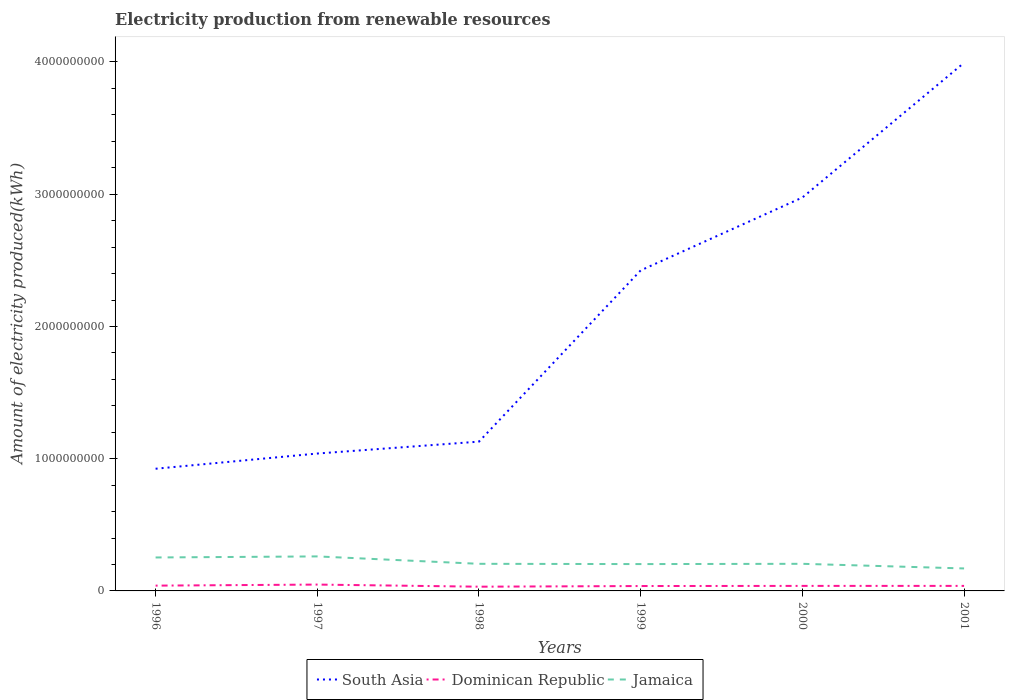Does the line corresponding to Dominican Republic intersect with the line corresponding to South Asia?
Give a very brief answer. No. Across all years, what is the maximum amount of electricity produced in South Asia?
Ensure brevity in your answer.  9.24e+08. In which year was the amount of electricity produced in Dominican Republic maximum?
Make the answer very short. 1998. What is the total amount of electricity produced in Dominican Republic in the graph?
Give a very brief answer. 2.00e+06. What is the difference between the highest and the second highest amount of electricity produced in Dominican Republic?
Give a very brief answer. 1.60e+07. What is the difference between the highest and the lowest amount of electricity produced in South Asia?
Make the answer very short. 3. Is the amount of electricity produced in South Asia strictly greater than the amount of electricity produced in Jamaica over the years?
Offer a very short reply. No. How many lines are there?
Make the answer very short. 3. How many years are there in the graph?
Your response must be concise. 6. Are the values on the major ticks of Y-axis written in scientific E-notation?
Keep it short and to the point. No. Does the graph contain grids?
Offer a very short reply. No. Where does the legend appear in the graph?
Keep it short and to the point. Bottom center. How many legend labels are there?
Ensure brevity in your answer.  3. How are the legend labels stacked?
Provide a succinct answer. Horizontal. What is the title of the graph?
Ensure brevity in your answer.  Electricity production from renewable resources. What is the label or title of the X-axis?
Offer a terse response. Years. What is the label or title of the Y-axis?
Give a very brief answer. Amount of electricity produced(kWh). What is the Amount of electricity produced(kWh) in South Asia in 1996?
Keep it short and to the point. 9.24e+08. What is the Amount of electricity produced(kWh) in Dominican Republic in 1996?
Offer a terse response. 4.00e+07. What is the Amount of electricity produced(kWh) of Jamaica in 1996?
Make the answer very short. 2.53e+08. What is the Amount of electricity produced(kWh) of South Asia in 1997?
Make the answer very short. 1.04e+09. What is the Amount of electricity produced(kWh) of Dominican Republic in 1997?
Offer a terse response. 4.80e+07. What is the Amount of electricity produced(kWh) in Jamaica in 1997?
Keep it short and to the point. 2.61e+08. What is the Amount of electricity produced(kWh) in South Asia in 1998?
Give a very brief answer. 1.13e+09. What is the Amount of electricity produced(kWh) in Dominican Republic in 1998?
Your response must be concise. 3.20e+07. What is the Amount of electricity produced(kWh) in Jamaica in 1998?
Provide a succinct answer. 2.05e+08. What is the Amount of electricity produced(kWh) in South Asia in 1999?
Keep it short and to the point. 2.42e+09. What is the Amount of electricity produced(kWh) of Dominican Republic in 1999?
Provide a succinct answer. 3.70e+07. What is the Amount of electricity produced(kWh) of Jamaica in 1999?
Give a very brief answer. 2.03e+08. What is the Amount of electricity produced(kWh) of South Asia in 2000?
Make the answer very short. 2.98e+09. What is the Amount of electricity produced(kWh) of Dominican Republic in 2000?
Keep it short and to the point. 3.80e+07. What is the Amount of electricity produced(kWh) of Jamaica in 2000?
Keep it short and to the point. 2.05e+08. What is the Amount of electricity produced(kWh) in South Asia in 2001?
Your answer should be very brief. 3.99e+09. What is the Amount of electricity produced(kWh) in Dominican Republic in 2001?
Your response must be concise. 3.80e+07. What is the Amount of electricity produced(kWh) of Jamaica in 2001?
Your answer should be very brief. 1.70e+08. Across all years, what is the maximum Amount of electricity produced(kWh) in South Asia?
Your answer should be very brief. 3.99e+09. Across all years, what is the maximum Amount of electricity produced(kWh) of Dominican Republic?
Make the answer very short. 4.80e+07. Across all years, what is the maximum Amount of electricity produced(kWh) of Jamaica?
Your answer should be compact. 2.61e+08. Across all years, what is the minimum Amount of electricity produced(kWh) in South Asia?
Offer a very short reply. 9.24e+08. Across all years, what is the minimum Amount of electricity produced(kWh) in Dominican Republic?
Your answer should be very brief. 3.20e+07. Across all years, what is the minimum Amount of electricity produced(kWh) in Jamaica?
Offer a terse response. 1.70e+08. What is the total Amount of electricity produced(kWh) of South Asia in the graph?
Make the answer very short. 1.25e+1. What is the total Amount of electricity produced(kWh) in Dominican Republic in the graph?
Your answer should be very brief. 2.33e+08. What is the total Amount of electricity produced(kWh) of Jamaica in the graph?
Give a very brief answer. 1.30e+09. What is the difference between the Amount of electricity produced(kWh) in South Asia in 1996 and that in 1997?
Offer a terse response. -1.15e+08. What is the difference between the Amount of electricity produced(kWh) of Dominican Republic in 1996 and that in 1997?
Make the answer very short. -8.00e+06. What is the difference between the Amount of electricity produced(kWh) in Jamaica in 1996 and that in 1997?
Offer a very short reply. -8.00e+06. What is the difference between the Amount of electricity produced(kWh) of South Asia in 1996 and that in 1998?
Provide a short and direct response. -2.05e+08. What is the difference between the Amount of electricity produced(kWh) in Dominican Republic in 1996 and that in 1998?
Give a very brief answer. 8.00e+06. What is the difference between the Amount of electricity produced(kWh) in Jamaica in 1996 and that in 1998?
Provide a short and direct response. 4.80e+07. What is the difference between the Amount of electricity produced(kWh) of South Asia in 1996 and that in 1999?
Your answer should be compact. -1.50e+09. What is the difference between the Amount of electricity produced(kWh) in Dominican Republic in 1996 and that in 1999?
Your answer should be very brief. 3.00e+06. What is the difference between the Amount of electricity produced(kWh) in South Asia in 1996 and that in 2000?
Your answer should be very brief. -2.05e+09. What is the difference between the Amount of electricity produced(kWh) of Dominican Republic in 1996 and that in 2000?
Your answer should be very brief. 2.00e+06. What is the difference between the Amount of electricity produced(kWh) in Jamaica in 1996 and that in 2000?
Give a very brief answer. 4.80e+07. What is the difference between the Amount of electricity produced(kWh) in South Asia in 1996 and that in 2001?
Ensure brevity in your answer.  -3.07e+09. What is the difference between the Amount of electricity produced(kWh) of Dominican Republic in 1996 and that in 2001?
Your answer should be very brief. 2.00e+06. What is the difference between the Amount of electricity produced(kWh) of Jamaica in 1996 and that in 2001?
Offer a very short reply. 8.30e+07. What is the difference between the Amount of electricity produced(kWh) of South Asia in 1997 and that in 1998?
Offer a terse response. -9.00e+07. What is the difference between the Amount of electricity produced(kWh) of Dominican Republic in 1997 and that in 1998?
Your answer should be compact. 1.60e+07. What is the difference between the Amount of electricity produced(kWh) in Jamaica in 1997 and that in 1998?
Ensure brevity in your answer.  5.60e+07. What is the difference between the Amount of electricity produced(kWh) of South Asia in 1997 and that in 1999?
Your answer should be compact. -1.38e+09. What is the difference between the Amount of electricity produced(kWh) in Dominican Republic in 1997 and that in 1999?
Ensure brevity in your answer.  1.10e+07. What is the difference between the Amount of electricity produced(kWh) in Jamaica in 1997 and that in 1999?
Make the answer very short. 5.80e+07. What is the difference between the Amount of electricity produced(kWh) in South Asia in 1997 and that in 2000?
Give a very brief answer. -1.94e+09. What is the difference between the Amount of electricity produced(kWh) in Jamaica in 1997 and that in 2000?
Your answer should be compact. 5.60e+07. What is the difference between the Amount of electricity produced(kWh) of South Asia in 1997 and that in 2001?
Provide a succinct answer. -2.96e+09. What is the difference between the Amount of electricity produced(kWh) in Dominican Republic in 1997 and that in 2001?
Make the answer very short. 1.00e+07. What is the difference between the Amount of electricity produced(kWh) in Jamaica in 1997 and that in 2001?
Your answer should be compact. 9.10e+07. What is the difference between the Amount of electricity produced(kWh) in South Asia in 1998 and that in 1999?
Keep it short and to the point. -1.30e+09. What is the difference between the Amount of electricity produced(kWh) in Dominican Republic in 1998 and that in 1999?
Offer a terse response. -5.00e+06. What is the difference between the Amount of electricity produced(kWh) of South Asia in 1998 and that in 2000?
Provide a short and direct response. -1.85e+09. What is the difference between the Amount of electricity produced(kWh) in Dominican Republic in 1998 and that in 2000?
Provide a succinct answer. -6.00e+06. What is the difference between the Amount of electricity produced(kWh) in Jamaica in 1998 and that in 2000?
Give a very brief answer. 0. What is the difference between the Amount of electricity produced(kWh) in South Asia in 1998 and that in 2001?
Ensure brevity in your answer.  -2.86e+09. What is the difference between the Amount of electricity produced(kWh) of Dominican Republic in 1998 and that in 2001?
Your answer should be compact. -6.00e+06. What is the difference between the Amount of electricity produced(kWh) of Jamaica in 1998 and that in 2001?
Ensure brevity in your answer.  3.50e+07. What is the difference between the Amount of electricity produced(kWh) in South Asia in 1999 and that in 2000?
Offer a terse response. -5.51e+08. What is the difference between the Amount of electricity produced(kWh) of Dominican Republic in 1999 and that in 2000?
Give a very brief answer. -1.00e+06. What is the difference between the Amount of electricity produced(kWh) of South Asia in 1999 and that in 2001?
Your answer should be compact. -1.57e+09. What is the difference between the Amount of electricity produced(kWh) in Dominican Republic in 1999 and that in 2001?
Your answer should be very brief. -1.00e+06. What is the difference between the Amount of electricity produced(kWh) of Jamaica in 1999 and that in 2001?
Your answer should be compact. 3.30e+07. What is the difference between the Amount of electricity produced(kWh) in South Asia in 2000 and that in 2001?
Provide a short and direct response. -1.02e+09. What is the difference between the Amount of electricity produced(kWh) of Dominican Republic in 2000 and that in 2001?
Keep it short and to the point. 0. What is the difference between the Amount of electricity produced(kWh) in Jamaica in 2000 and that in 2001?
Provide a short and direct response. 3.50e+07. What is the difference between the Amount of electricity produced(kWh) of South Asia in 1996 and the Amount of electricity produced(kWh) of Dominican Republic in 1997?
Offer a very short reply. 8.76e+08. What is the difference between the Amount of electricity produced(kWh) of South Asia in 1996 and the Amount of electricity produced(kWh) of Jamaica in 1997?
Make the answer very short. 6.63e+08. What is the difference between the Amount of electricity produced(kWh) of Dominican Republic in 1996 and the Amount of electricity produced(kWh) of Jamaica in 1997?
Provide a succinct answer. -2.21e+08. What is the difference between the Amount of electricity produced(kWh) of South Asia in 1996 and the Amount of electricity produced(kWh) of Dominican Republic in 1998?
Your response must be concise. 8.92e+08. What is the difference between the Amount of electricity produced(kWh) of South Asia in 1996 and the Amount of electricity produced(kWh) of Jamaica in 1998?
Offer a very short reply. 7.19e+08. What is the difference between the Amount of electricity produced(kWh) of Dominican Republic in 1996 and the Amount of electricity produced(kWh) of Jamaica in 1998?
Keep it short and to the point. -1.65e+08. What is the difference between the Amount of electricity produced(kWh) in South Asia in 1996 and the Amount of electricity produced(kWh) in Dominican Republic in 1999?
Your answer should be compact. 8.87e+08. What is the difference between the Amount of electricity produced(kWh) of South Asia in 1996 and the Amount of electricity produced(kWh) of Jamaica in 1999?
Make the answer very short. 7.21e+08. What is the difference between the Amount of electricity produced(kWh) of Dominican Republic in 1996 and the Amount of electricity produced(kWh) of Jamaica in 1999?
Provide a short and direct response. -1.63e+08. What is the difference between the Amount of electricity produced(kWh) in South Asia in 1996 and the Amount of electricity produced(kWh) in Dominican Republic in 2000?
Ensure brevity in your answer.  8.86e+08. What is the difference between the Amount of electricity produced(kWh) in South Asia in 1996 and the Amount of electricity produced(kWh) in Jamaica in 2000?
Offer a terse response. 7.19e+08. What is the difference between the Amount of electricity produced(kWh) of Dominican Republic in 1996 and the Amount of electricity produced(kWh) of Jamaica in 2000?
Give a very brief answer. -1.65e+08. What is the difference between the Amount of electricity produced(kWh) of South Asia in 1996 and the Amount of electricity produced(kWh) of Dominican Republic in 2001?
Give a very brief answer. 8.86e+08. What is the difference between the Amount of electricity produced(kWh) of South Asia in 1996 and the Amount of electricity produced(kWh) of Jamaica in 2001?
Offer a terse response. 7.54e+08. What is the difference between the Amount of electricity produced(kWh) in Dominican Republic in 1996 and the Amount of electricity produced(kWh) in Jamaica in 2001?
Your answer should be very brief. -1.30e+08. What is the difference between the Amount of electricity produced(kWh) of South Asia in 1997 and the Amount of electricity produced(kWh) of Dominican Republic in 1998?
Your answer should be very brief. 1.01e+09. What is the difference between the Amount of electricity produced(kWh) in South Asia in 1997 and the Amount of electricity produced(kWh) in Jamaica in 1998?
Ensure brevity in your answer.  8.34e+08. What is the difference between the Amount of electricity produced(kWh) in Dominican Republic in 1997 and the Amount of electricity produced(kWh) in Jamaica in 1998?
Make the answer very short. -1.57e+08. What is the difference between the Amount of electricity produced(kWh) of South Asia in 1997 and the Amount of electricity produced(kWh) of Dominican Republic in 1999?
Your answer should be very brief. 1.00e+09. What is the difference between the Amount of electricity produced(kWh) in South Asia in 1997 and the Amount of electricity produced(kWh) in Jamaica in 1999?
Provide a short and direct response. 8.36e+08. What is the difference between the Amount of electricity produced(kWh) in Dominican Republic in 1997 and the Amount of electricity produced(kWh) in Jamaica in 1999?
Offer a terse response. -1.55e+08. What is the difference between the Amount of electricity produced(kWh) in South Asia in 1997 and the Amount of electricity produced(kWh) in Dominican Republic in 2000?
Your answer should be compact. 1.00e+09. What is the difference between the Amount of electricity produced(kWh) in South Asia in 1997 and the Amount of electricity produced(kWh) in Jamaica in 2000?
Offer a very short reply. 8.34e+08. What is the difference between the Amount of electricity produced(kWh) in Dominican Republic in 1997 and the Amount of electricity produced(kWh) in Jamaica in 2000?
Your response must be concise. -1.57e+08. What is the difference between the Amount of electricity produced(kWh) of South Asia in 1997 and the Amount of electricity produced(kWh) of Dominican Republic in 2001?
Provide a short and direct response. 1.00e+09. What is the difference between the Amount of electricity produced(kWh) of South Asia in 1997 and the Amount of electricity produced(kWh) of Jamaica in 2001?
Make the answer very short. 8.69e+08. What is the difference between the Amount of electricity produced(kWh) in Dominican Republic in 1997 and the Amount of electricity produced(kWh) in Jamaica in 2001?
Offer a very short reply. -1.22e+08. What is the difference between the Amount of electricity produced(kWh) of South Asia in 1998 and the Amount of electricity produced(kWh) of Dominican Republic in 1999?
Provide a short and direct response. 1.09e+09. What is the difference between the Amount of electricity produced(kWh) in South Asia in 1998 and the Amount of electricity produced(kWh) in Jamaica in 1999?
Make the answer very short. 9.26e+08. What is the difference between the Amount of electricity produced(kWh) of Dominican Republic in 1998 and the Amount of electricity produced(kWh) of Jamaica in 1999?
Ensure brevity in your answer.  -1.71e+08. What is the difference between the Amount of electricity produced(kWh) of South Asia in 1998 and the Amount of electricity produced(kWh) of Dominican Republic in 2000?
Your response must be concise. 1.09e+09. What is the difference between the Amount of electricity produced(kWh) in South Asia in 1998 and the Amount of electricity produced(kWh) in Jamaica in 2000?
Ensure brevity in your answer.  9.24e+08. What is the difference between the Amount of electricity produced(kWh) in Dominican Republic in 1998 and the Amount of electricity produced(kWh) in Jamaica in 2000?
Provide a succinct answer. -1.73e+08. What is the difference between the Amount of electricity produced(kWh) in South Asia in 1998 and the Amount of electricity produced(kWh) in Dominican Republic in 2001?
Provide a succinct answer. 1.09e+09. What is the difference between the Amount of electricity produced(kWh) of South Asia in 1998 and the Amount of electricity produced(kWh) of Jamaica in 2001?
Offer a very short reply. 9.59e+08. What is the difference between the Amount of electricity produced(kWh) in Dominican Republic in 1998 and the Amount of electricity produced(kWh) in Jamaica in 2001?
Provide a succinct answer. -1.38e+08. What is the difference between the Amount of electricity produced(kWh) in South Asia in 1999 and the Amount of electricity produced(kWh) in Dominican Republic in 2000?
Offer a very short reply. 2.39e+09. What is the difference between the Amount of electricity produced(kWh) in South Asia in 1999 and the Amount of electricity produced(kWh) in Jamaica in 2000?
Offer a terse response. 2.22e+09. What is the difference between the Amount of electricity produced(kWh) of Dominican Republic in 1999 and the Amount of electricity produced(kWh) of Jamaica in 2000?
Keep it short and to the point. -1.68e+08. What is the difference between the Amount of electricity produced(kWh) of South Asia in 1999 and the Amount of electricity produced(kWh) of Dominican Republic in 2001?
Provide a succinct answer. 2.39e+09. What is the difference between the Amount of electricity produced(kWh) in South Asia in 1999 and the Amount of electricity produced(kWh) in Jamaica in 2001?
Provide a succinct answer. 2.25e+09. What is the difference between the Amount of electricity produced(kWh) of Dominican Republic in 1999 and the Amount of electricity produced(kWh) of Jamaica in 2001?
Ensure brevity in your answer.  -1.33e+08. What is the difference between the Amount of electricity produced(kWh) of South Asia in 2000 and the Amount of electricity produced(kWh) of Dominican Republic in 2001?
Make the answer very short. 2.94e+09. What is the difference between the Amount of electricity produced(kWh) of South Asia in 2000 and the Amount of electricity produced(kWh) of Jamaica in 2001?
Provide a succinct answer. 2.80e+09. What is the difference between the Amount of electricity produced(kWh) of Dominican Republic in 2000 and the Amount of electricity produced(kWh) of Jamaica in 2001?
Make the answer very short. -1.32e+08. What is the average Amount of electricity produced(kWh) in South Asia per year?
Keep it short and to the point. 2.08e+09. What is the average Amount of electricity produced(kWh) in Dominican Republic per year?
Keep it short and to the point. 3.88e+07. What is the average Amount of electricity produced(kWh) in Jamaica per year?
Your answer should be very brief. 2.16e+08. In the year 1996, what is the difference between the Amount of electricity produced(kWh) of South Asia and Amount of electricity produced(kWh) of Dominican Republic?
Keep it short and to the point. 8.84e+08. In the year 1996, what is the difference between the Amount of electricity produced(kWh) in South Asia and Amount of electricity produced(kWh) in Jamaica?
Your answer should be compact. 6.71e+08. In the year 1996, what is the difference between the Amount of electricity produced(kWh) of Dominican Republic and Amount of electricity produced(kWh) of Jamaica?
Offer a terse response. -2.13e+08. In the year 1997, what is the difference between the Amount of electricity produced(kWh) of South Asia and Amount of electricity produced(kWh) of Dominican Republic?
Provide a succinct answer. 9.91e+08. In the year 1997, what is the difference between the Amount of electricity produced(kWh) of South Asia and Amount of electricity produced(kWh) of Jamaica?
Give a very brief answer. 7.78e+08. In the year 1997, what is the difference between the Amount of electricity produced(kWh) of Dominican Republic and Amount of electricity produced(kWh) of Jamaica?
Ensure brevity in your answer.  -2.13e+08. In the year 1998, what is the difference between the Amount of electricity produced(kWh) in South Asia and Amount of electricity produced(kWh) in Dominican Republic?
Provide a short and direct response. 1.10e+09. In the year 1998, what is the difference between the Amount of electricity produced(kWh) of South Asia and Amount of electricity produced(kWh) of Jamaica?
Your response must be concise. 9.24e+08. In the year 1998, what is the difference between the Amount of electricity produced(kWh) of Dominican Republic and Amount of electricity produced(kWh) of Jamaica?
Give a very brief answer. -1.73e+08. In the year 1999, what is the difference between the Amount of electricity produced(kWh) of South Asia and Amount of electricity produced(kWh) of Dominican Republic?
Your answer should be compact. 2.39e+09. In the year 1999, what is the difference between the Amount of electricity produced(kWh) of South Asia and Amount of electricity produced(kWh) of Jamaica?
Ensure brevity in your answer.  2.22e+09. In the year 1999, what is the difference between the Amount of electricity produced(kWh) in Dominican Republic and Amount of electricity produced(kWh) in Jamaica?
Offer a terse response. -1.66e+08. In the year 2000, what is the difference between the Amount of electricity produced(kWh) in South Asia and Amount of electricity produced(kWh) in Dominican Republic?
Your answer should be very brief. 2.94e+09. In the year 2000, what is the difference between the Amount of electricity produced(kWh) of South Asia and Amount of electricity produced(kWh) of Jamaica?
Keep it short and to the point. 2.77e+09. In the year 2000, what is the difference between the Amount of electricity produced(kWh) of Dominican Republic and Amount of electricity produced(kWh) of Jamaica?
Provide a succinct answer. -1.67e+08. In the year 2001, what is the difference between the Amount of electricity produced(kWh) in South Asia and Amount of electricity produced(kWh) in Dominican Republic?
Ensure brevity in your answer.  3.96e+09. In the year 2001, what is the difference between the Amount of electricity produced(kWh) in South Asia and Amount of electricity produced(kWh) in Jamaica?
Make the answer very short. 3.82e+09. In the year 2001, what is the difference between the Amount of electricity produced(kWh) in Dominican Republic and Amount of electricity produced(kWh) in Jamaica?
Your answer should be compact. -1.32e+08. What is the ratio of the Amount of electricity produced(kWh) in South Asia in 1996 to that in 1997?
Ensure brevity in your answer.  0.89. What is the ratio of the Amount of electricity produced(kWh) of Jamaica in 1996 to that in 1997?
Ensure brevity in your answer.  0.97. What is the ratio of the Amount of electricity produced(kWh) of South Asia in 1996 to that in 1998?
Offer a very short reply. 0.82. What is the ratio of the Amount of electricity produced(kWh) of Jamaica in 1996 to that in 1998?
Your answer should be very brief. 1.23. What is the ratio of the Amount of electricity produced(kWh) of South Asia in 1996 to that in 1999?
Provide a short and direct response. 0.38. What is the ratio of the Amount of electricity produced(kWh) of Dominican Republic in 1996 to that in 1999?
Make the answer very short. 1.08. What is the ratio of the Amount of electricity produced(kWh) in Jamaica in 1996 to that in 1999?
Make the answer very short. 1.25. What is the ratio of the Amount of electricity produced(kWh) of South Asia in 1996 to that in 2000?
Make the answer very short. 0.31. What is the ratio of the Amount of electricity produced(kWh) in Dominican Republic in 1996 to that in 2000?
Keep it short and to the point. 1.05. What is the ratio of the Amount of electricity produced(kWh) in Jamaica in 1996 to that in 2000?
Your answer should be compact. 1.23. What is the ratio of the Amount of electricity produced(kWh) of South Asia in 1996 to that in 2001?
Keep it short and to the point. 0.23. What is the ratio of the Amount of electricity produced(kWh) of Dominican Republic in 1996 to that in 2001?
Provide a succinct answer. 1.05. What is the ratio of the Amount of electricity produced(kWh) of Jamaica in 1996 to that in 2001?
Offer a terse response. 1.49. What is the ratio of the Amount of electricity produced(kWh) of South Asia in 1997 to that in 1998?
Offer a very short reply. 0.92. What is the ratio of the Amount of electricity produced(kWh) of Dominican Republic in 1997 to that in 1998?
Your answer should be compact. 1.5. What is the ratio of the Amount of electricity produced(kWh) in Jamaica in 1997 to that in 1998?
Provide a short and direct response. 1.27. What is the ratio of the Amount of electricity produced(kWh) in South Asia in 1997 to that in 1999?
Make the answer very short. 0.43. What is the ratio of the Amount of electricity produced(kWh) in Dominican Republic in 1997 to that in 1999?
Ensure brevity in your answer.  1.3. What is the ratio of the Amount of electricity produced(kWh) of South Asia in 1997 to that in 2000?
Your response must be concise. 0.35. What is the ratio of the Amount of electricity produced(kWh) of Dominican Republic in 1997 to that in 2000?
Provide a short and direct response. 1.26. What is the ratio of the Amount of electricity produced(kWh) of Jamaica in 1997 to that in 2000?
Keep it short and to the point. 1.27. What is the ratio of the Amount of electricity produced(kWh) in South Asia in 1997 to that in 2001?
Ensure brevity in your answer.  0.26. What is the ratio of the Amount of electricity produced(kWh) of Dominican Republic in 1997 to that in 2001?
Your answer should be compact. 1.26. What is the ratio of the Amount of electricity produced(kWh) of Jamaica in 1997 to that in 2001?
Offer a very short reply. 1.54. What is the ratio of the Amount of electricity produced(kWh) of South Asia in 1998 to that in 1999?
Offer a very short reply. 0.47. What is the ratio of the Amount of electricity produced(kWh) in Dominican Republic in 1998 to that in 1999?
Your answer should be very brief. 0.86. What is the ratio of the Amount of electricity produced(kWh) of Jamaica in 1998 to that in 1999?
Your answer should be very brief. 1.01. What is the ratio of the Amount of electricity produced(kWh) of South Asia in 1998 to that in 2000?
Ensure brevity in your answer.  0.38. What is the ratio of the Amount of electricity produced(kWh) in Dominican Republic in 1998 to that in 2000?
Make the answer very short. 0.84. What is the ratio of the Amount of electricity produced(kWh) in South Asia in 1998 to that in 2001?
Give a very brief answer. 0.28. What is the ratio of the Amount of electricity produced(kWh) of Dominican Republic in 1998 to that in 2001?
Offer a very short reply. 0.84. What is the ratio of the Amount of electricity produced(kWh) in Jamaica in 1998 to that in 2001?
Ensure brevity in your answer.  1.21. What is the ratio of the Amount of electricity produced(kWh) of South Asia in 1999 to that in 2000?
Your answer should be very brief. 0.81. What is the ratio of the Amount of electricity produced(kWh) of Dominican Republic in 1999 to that in 2000?
Your answer should be compact. 0.97. What is the ratio of the Amount of electricity produced(kWh) in Jamaica in 1999 to that in 2000?
Your answer should be compact. 0.99. What is the ratio of the Amount of electricity produced(kWh) of South Asia in 1999 to that in 2001?
Provide a succinct answer. 0.61. What is the ratio of the Amount of electricity produced(kWh) of Dominican Republic in 1999 to that in 2001?
Provide a succinct answer. 0.97. What is the ratio of the Amount of electricity produced(kWh) of Jamaica in 1999 to that in 2001?
Your answer should be very brief. 1.19. What is the ratio of the Amount of electricity produced(kWh) of South Asia in 2000 to that in 2001?
Provide a succinct answer. 0.74. What is the ratio of the Amount of electricity produced(kWh) in Jamaica in 2000 to that in 2001?
Your answer should be very brief. 1.21. What is the difference between the highest and the second highest Amount of electricity produced(kWh) of South Asia?
Ensure brevity in your answer.  1.02e+09. What is the difference between the highest and the second highest Amount of electricity produced(kWh) of Dominican Republic?
Provide a succinct answer. 8.00e+06. What is the difference between the highest and the second highest Amount of electricity produced(kWh) of Jamaica?
Keep it short and to the point. 8.00e+06. What is the difference between the highest and the lowest Amount of electricity produced(kWh) of South Asia?
Ensure brevity in your answer.  3.07e+09. What is the difference between the highest and the lowest Amount of electricity produced(kWh) of Dominican Republic?
Keep it short and to the point. 1.60e+07. What is the difference between the highest and the lowest Amount of electricity produced(kWh) in Jamaica?
Make the answer very short. 9.10e+07. 